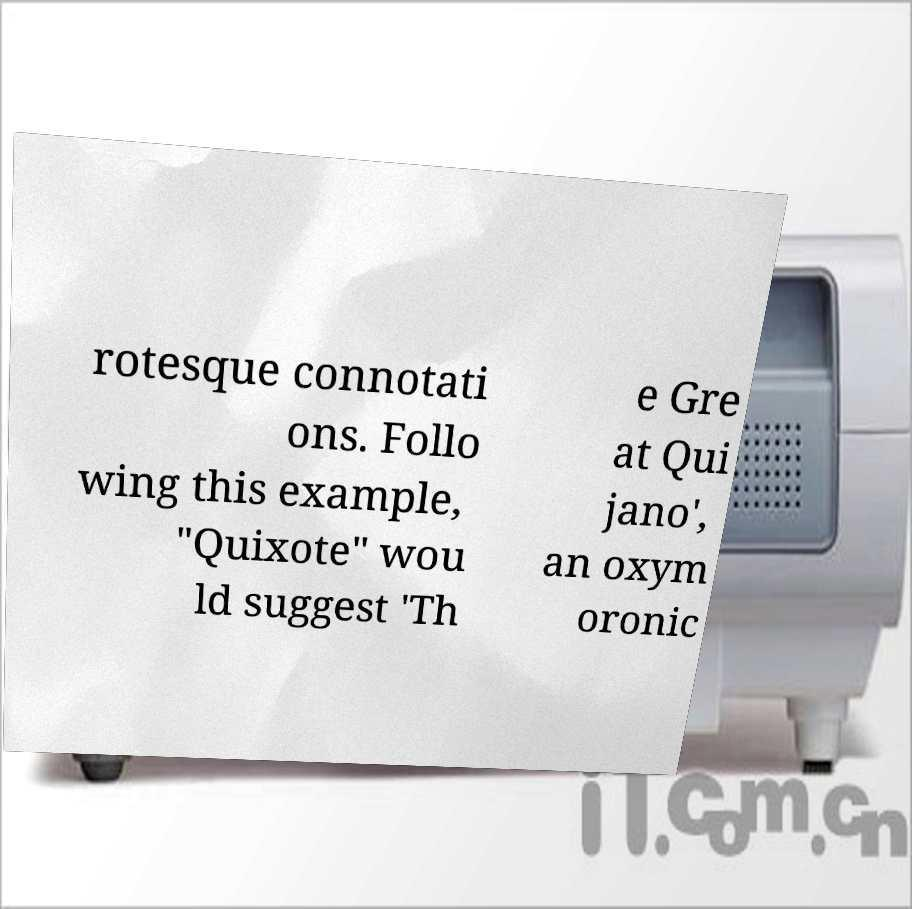I need the written content from this picture converted into text. Can you do that? rotesque connotati ons. Follo wing this example, "Quixote" wou ld suggest 'Th e Gre at Qui jano', an oxym oronic 